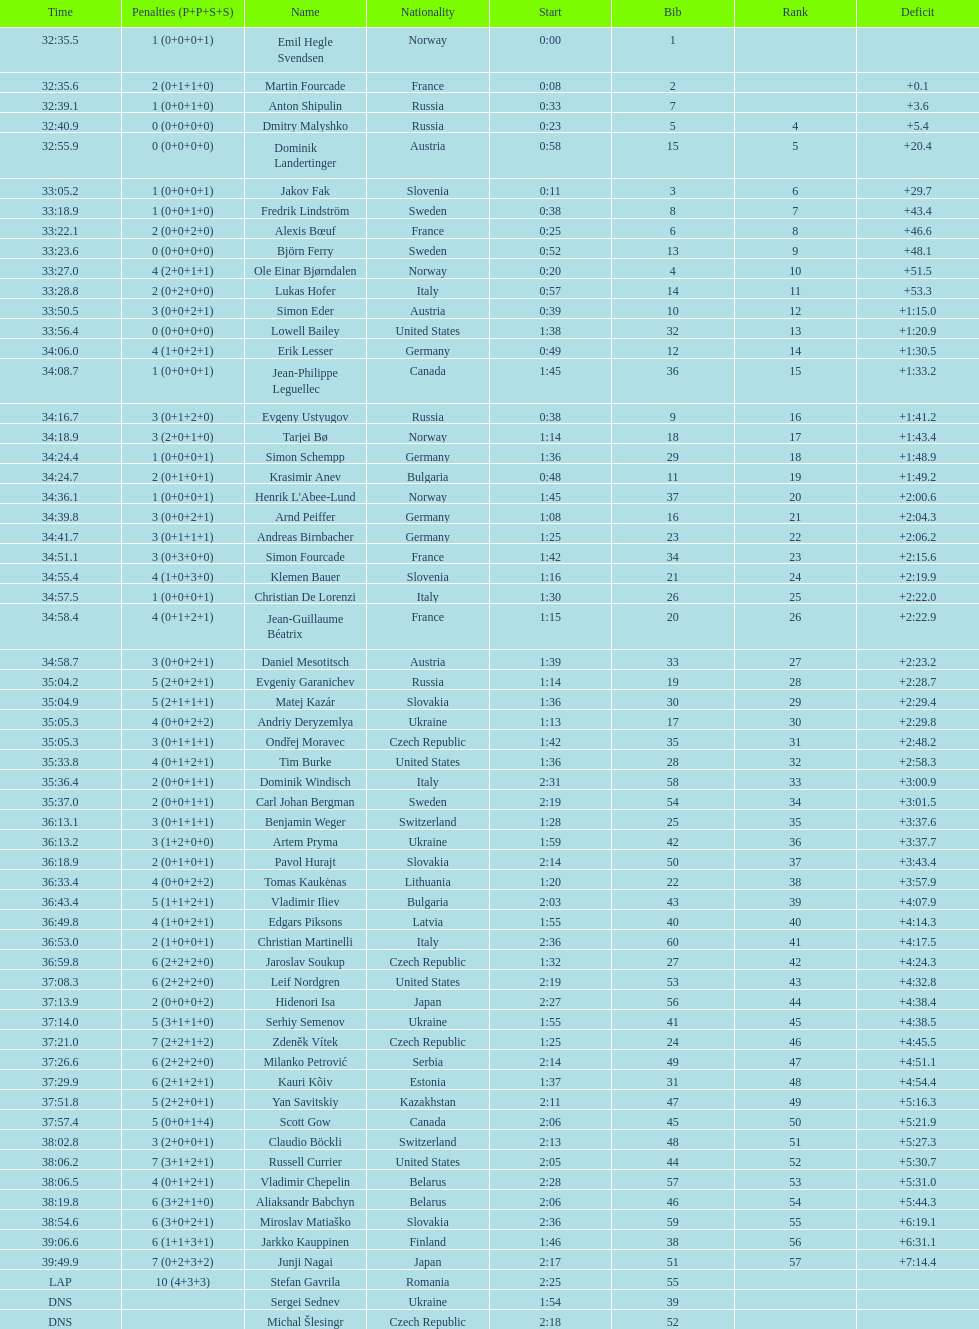Between bjorn ferry, simon elder and erik lesser - who had the most penalties? Erik Lesser. 